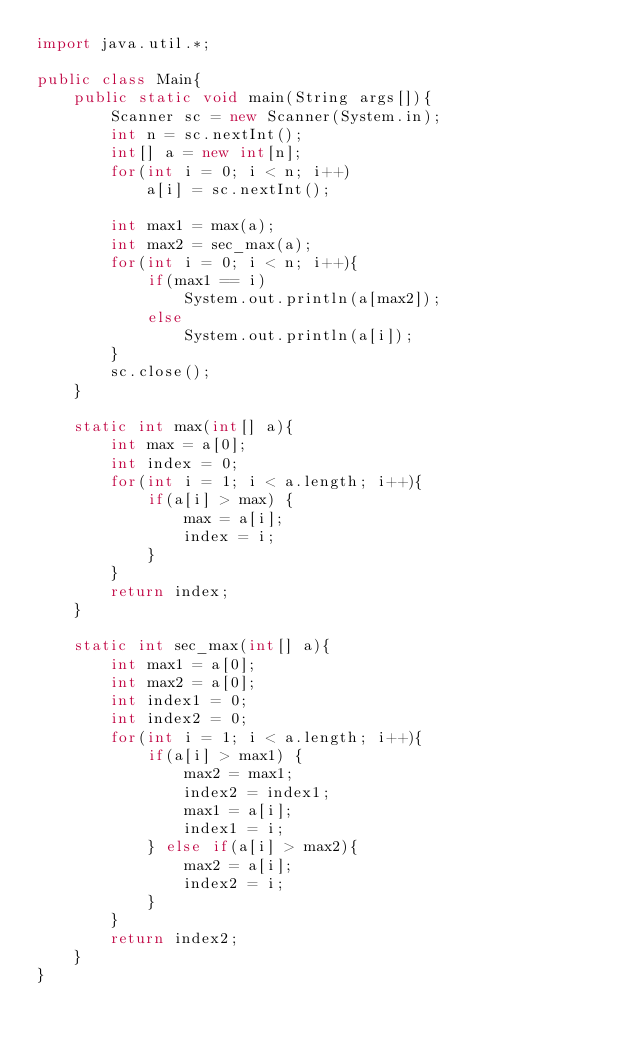Convert code to text. <code><loc_0><loc_0><loc_500><loc_500><_Java_>import java.util.*;

public class Main{
    public static void main(String args[]){
        Scanner sc = new Scanner(System.in);
        int n = sc.nextInt();
        int[] a = new int[n];
        for(int i = 0; i < n; i++)
            a[i] = sc.nextInt();
        
        int max1 = max(a);
        int max2 = sec_max(a);
        for(int i = 0; i < n; i++){
            if(max1 == i)
                System.out.println(a[max2]);
            else
                System.out.println(a[i]);
        }
        sc.close();  
    }

    static int max(int[] a){
        int max = a[0];
        int index = 0;
        for(int i = 1; i < a.length; i++){
            if(a[i] > max) {
                max = a[i];
                index = i;
            }
        }
        return index;
    }

    static int sec_max(int[] a){
        int max1 = a[0];
        int max2 = a[0];
        int index1 = 0;
        int index2 = 0;
        for(int i = 1; i < a.length; i++){
            if(a[i] > max1) {
                max2 = max1;
                index2 = index1;
                max1 = a[i];
                index1 = i;
            } else if(a[i] > max2){
                max2 = a[i];
                index2 = i;
            }
        }
        return index2;
    }
}</code> 